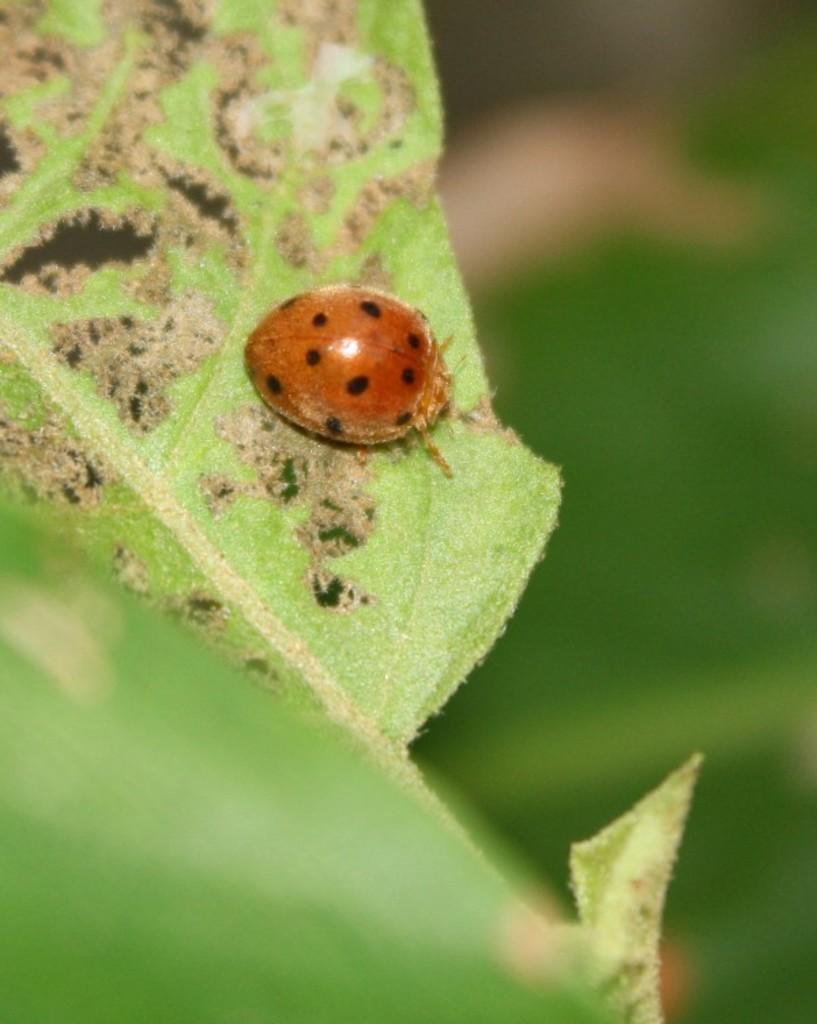In one or two sentences, can you explain what this image depicts? In this image there is an insect on the leaf. Background is blurry. 